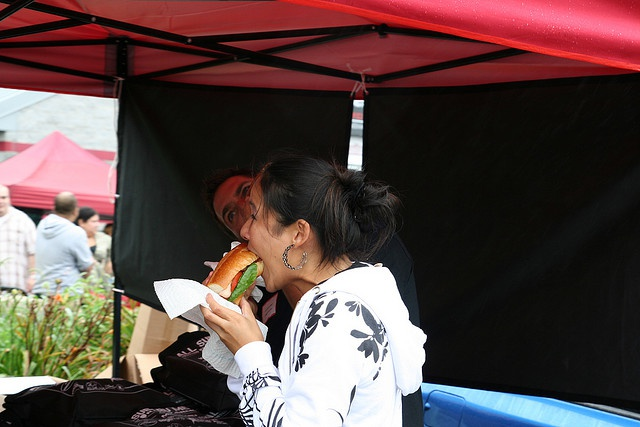Describe the objects in this image and their specific colors. I can see people in black, white, brown, and tan tones, people in black, lightgray, darkgray, and beige tones, people in black, white, pink, tan, and darkgray tones, sandwich in black, orange, red, brown, and tan tones, and people in black, maroon, and brown tones in this image. 